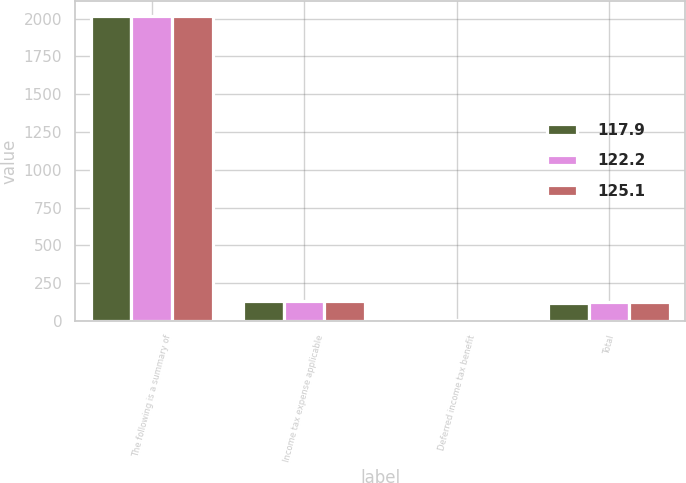Convert chart to OTSL. <chart><loc_0><loc_0><loc_500><loc_500><stacked_bar_chart><ecel><fcel>The following is a summary of<fcel>Income tax expense applicable<fcel>Deferred income tax benefit<fcel>Total<nl><fcel>117.9<fcel>2016<fcel>128.5<fcel>10.6<fcel>117.9<nl><fcel>122.2<fcel>2015<fcel>130.4<fcel>5.3<fcel>125.1<nl><fcel>125.1<fcel>2014<fcel>128.9<fcel>6.7<fcel>122.2<nl></chart> 